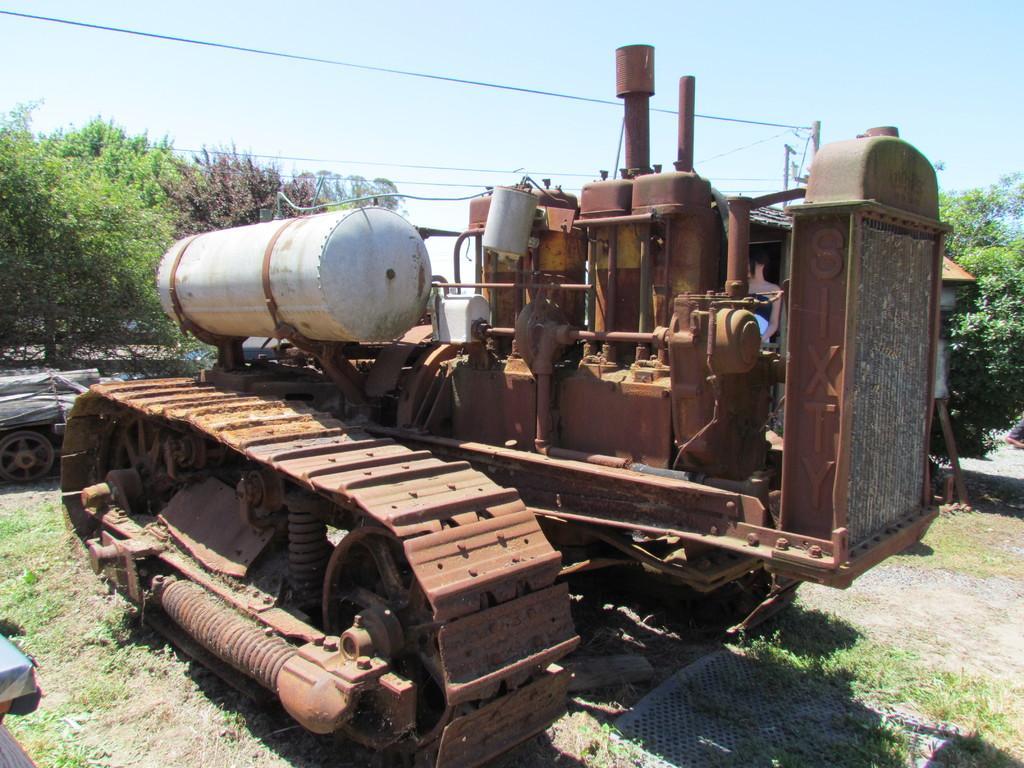How would you summarize this image in a sentence or two? In this image I can see a machine on the ground. In the background there are many trees. At the top of the image I can see the sky. On the left side there is an object which seems to be a vehicle. 